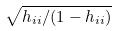Convert formula to latex. <formula><loc_0><loc_0><loc_500><loc_500>\sqrt { h _ { i i } / ( 1 - h _ { i i } ) }</formula> 